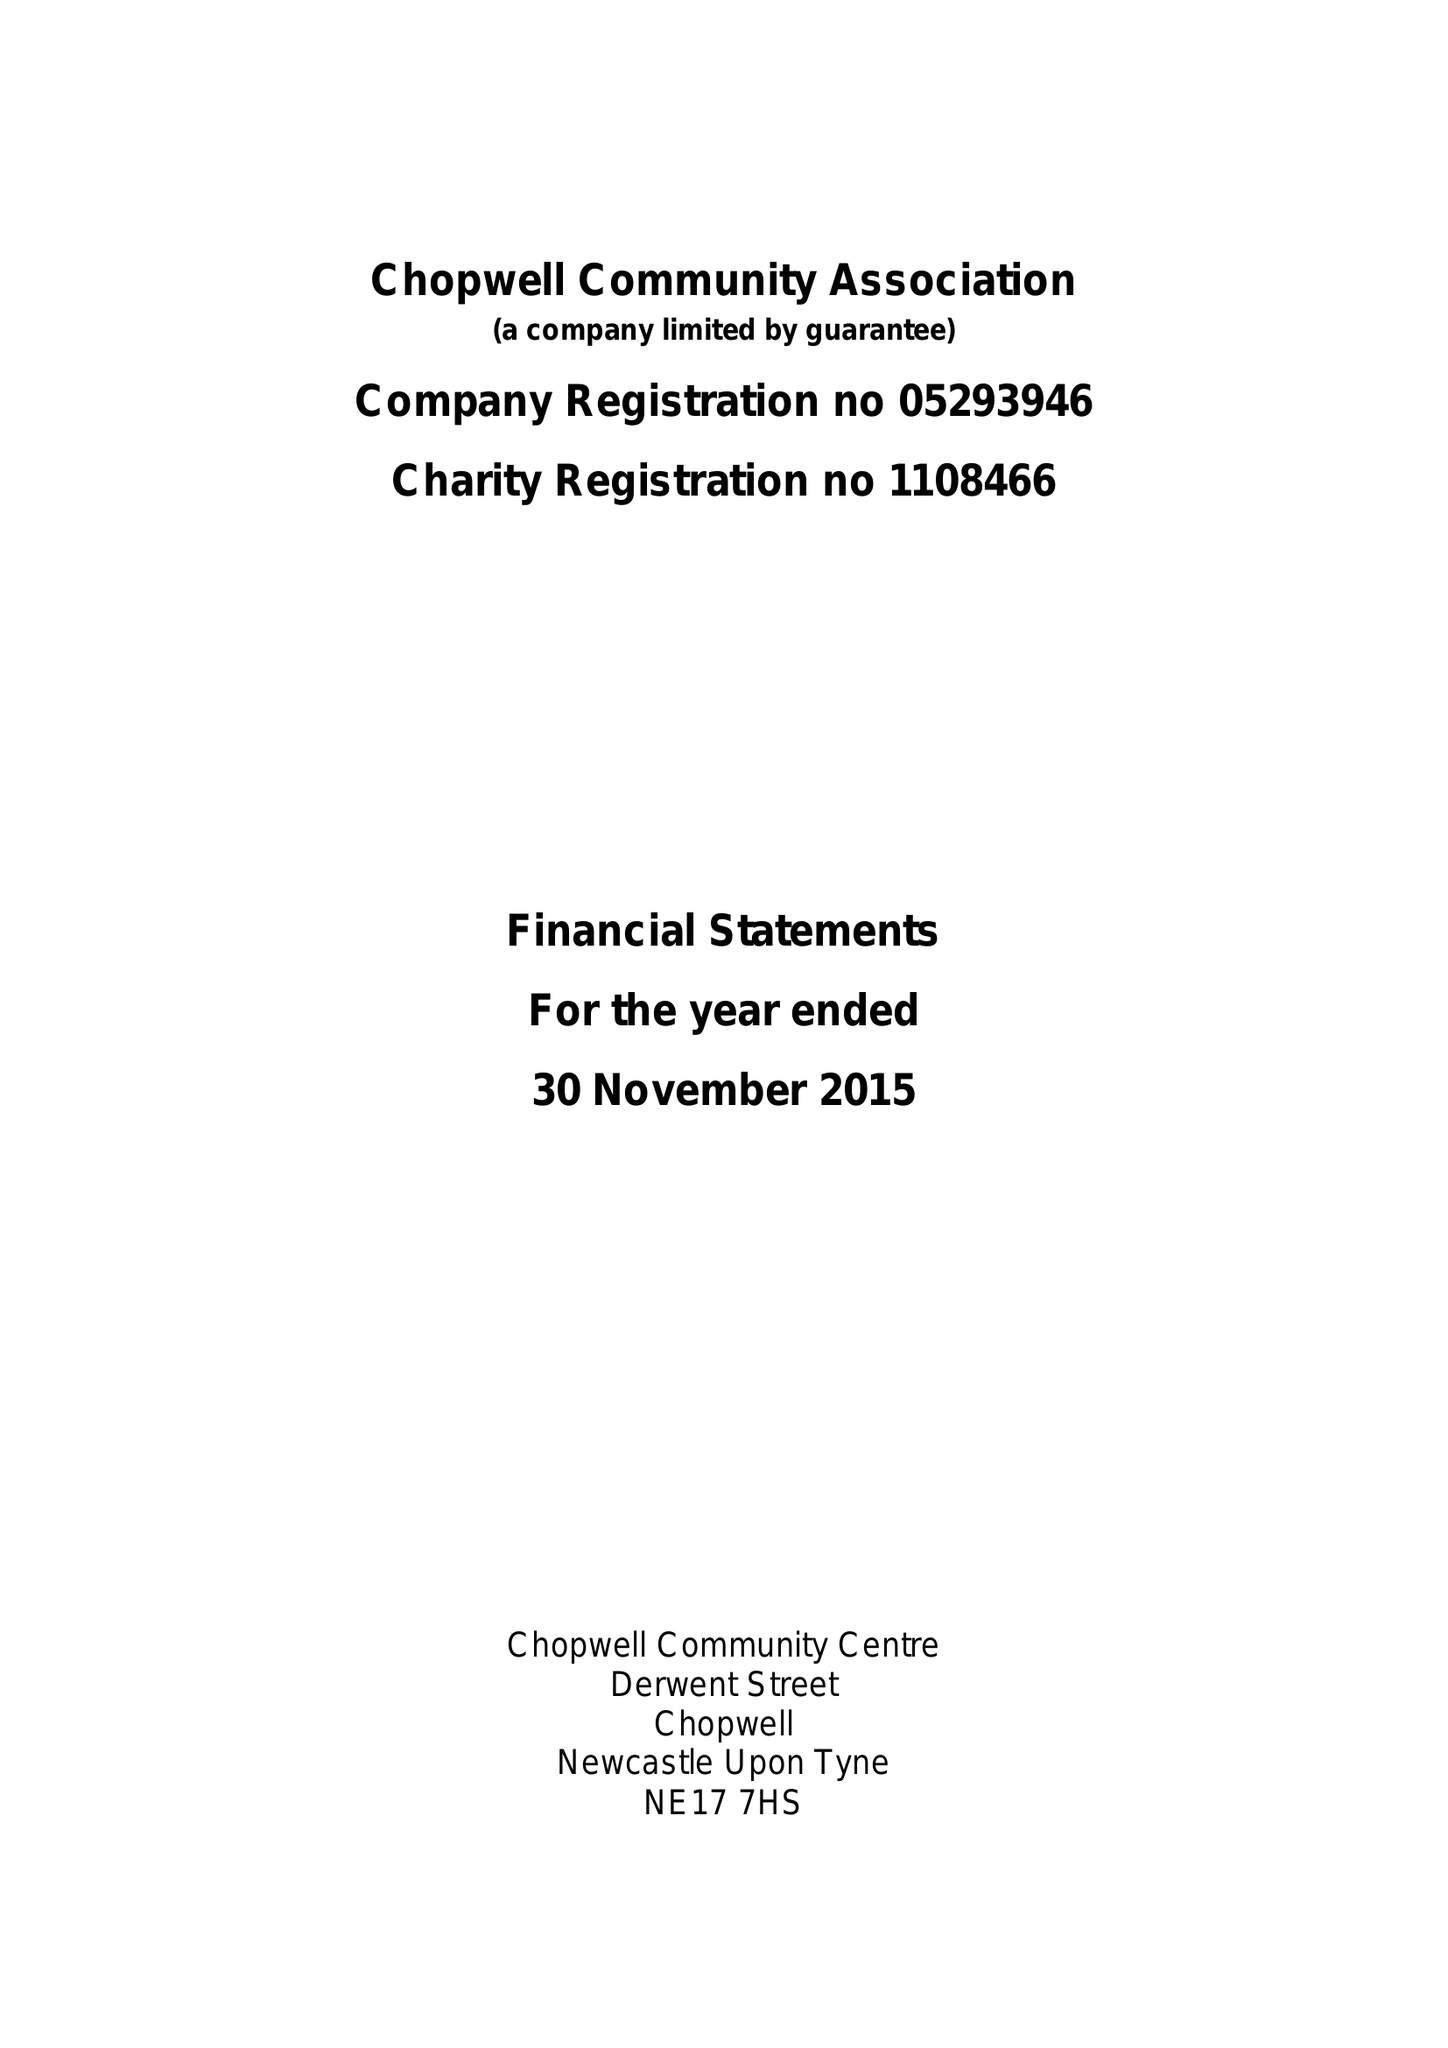What is the value for the report_date?
Answer the question using a single word or phrase. 2015-11-30 